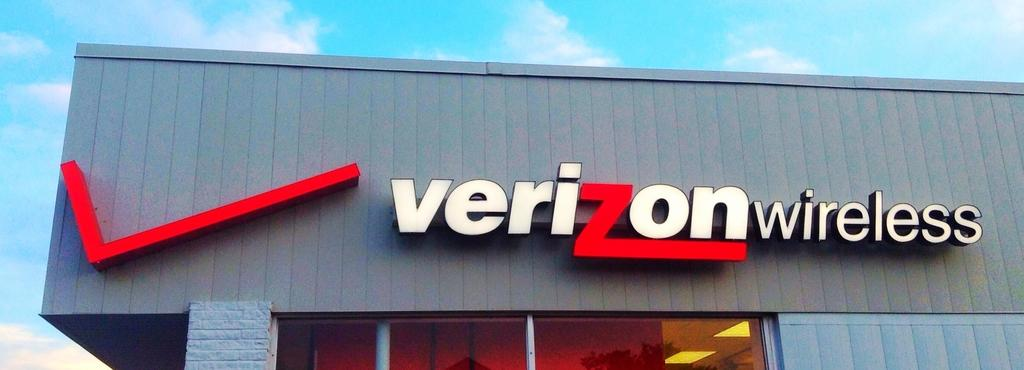What is the main subject of the image? The main subject of the image is a company name. Where is the company name located in relation to the organization? The company name is in front of an organization. How many legs does the kitty have in the image? There is no kitty present in the image. What type of plant is growing next to the company name in the image? There is no plant present in the image. 